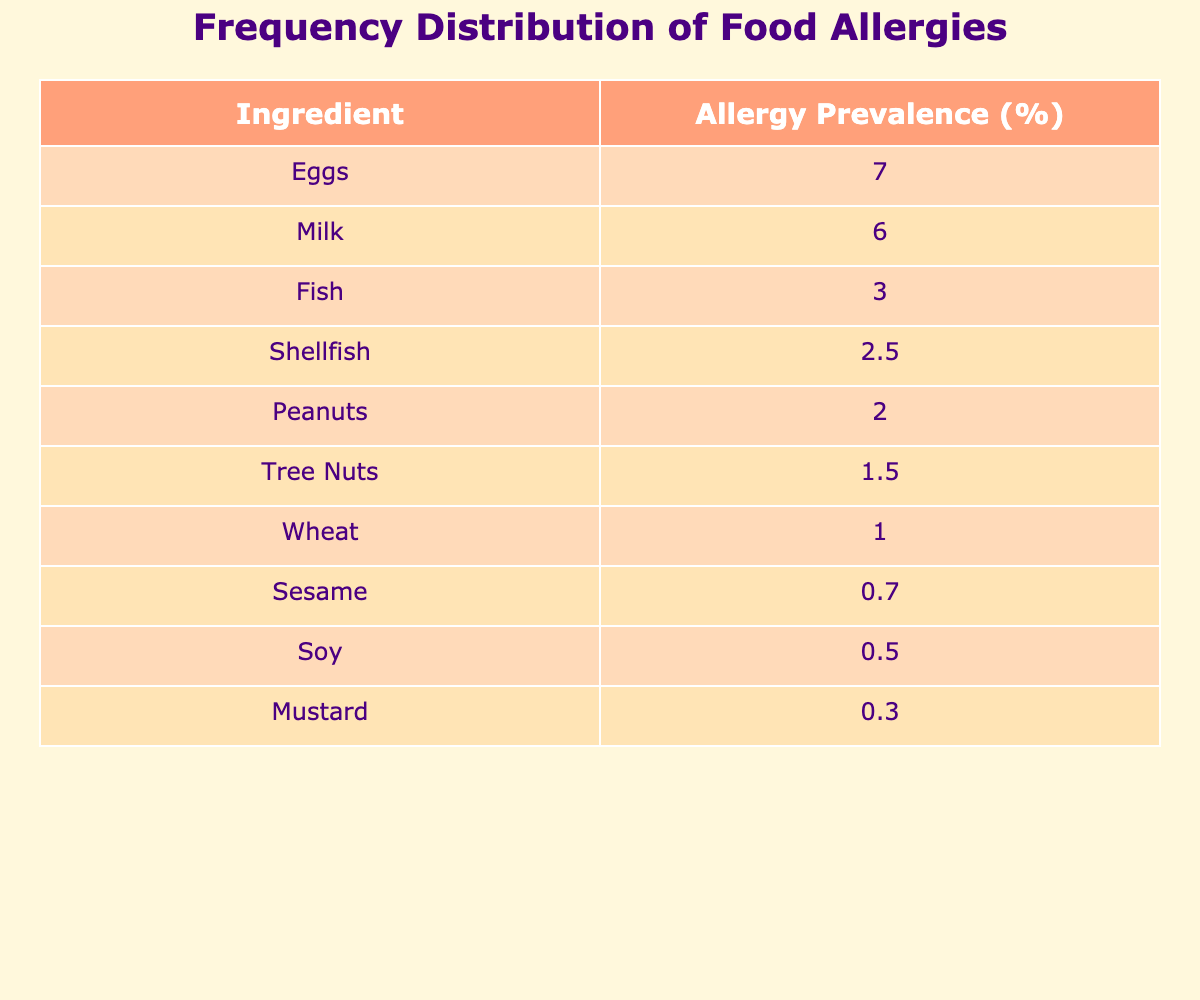What is the ingredient with the highest allergy prevalence? The table shows that the ingredient with the highest allergy prevalence is Eggs at 7%.
Answer: Eggs What is the total allergy prevalence percentage of Peanuts and Tree Nuts combined? The allergy prevalence of Peanuts is 2% and Tree Nuts is 1.5%. Adding these values together gives 2 + 1.5 = 3.5%.
Answer: 3.5% Is the allergy prevalence of Soy higher than that of Mustard? The table lists the allergy prevalence of Soy at 0.5% and Mustard at 0.3%. Since 0.5% is greater than 0.3%, the statement is true.
Answer: Yes What is the median allergy prevalence among the listed ingredients? To find the median, we need to arrange the allergy prevalence percentages in ascending order: 0.3, 0.5, 0.7, 1, 1.5, 2, 2.5, 3, 6, 7. There are 10 values, so the median is the average of the 5th and 6th values: (2 + 2.5) / 2 = 2.25%.
Answer: 2.25% Which ingredient has a greater allergy prevalence, Fish or Shellfish? The allergy prevalence for Fish is 3% and for Shellfish is 2.5%. Since 3% is greater than 2.5%, Fish has the higher prevalence.
Answer: Fish What percentage of the ingredients have an allergy prevalence of 1% or less? The ingredients with 1% or less are Soy (0.5%), Mustard (0.3%), and Wheat (1%). This totals 3 ingredients out of 10, which gives a percentage of (3 / 10) * 100 = 30%.
Answer: 30% Is the allergy prevalence for Milk greater than both Fish and Shellfish? The prevalence for Milk is 6%, Fish is 3%, and Shellfish is 2.5%. Since 6% is greater than both 3% and 2.5%, the statement is true.
Answer: Yes What is the sum of the allergy prevalence percentages for Milk and Eggs? The allergy prevalence for Milk is 6% and for Eggs is 7%. Adding these two percentages gives 6 + 7 = 13%.
Answer: 13% 